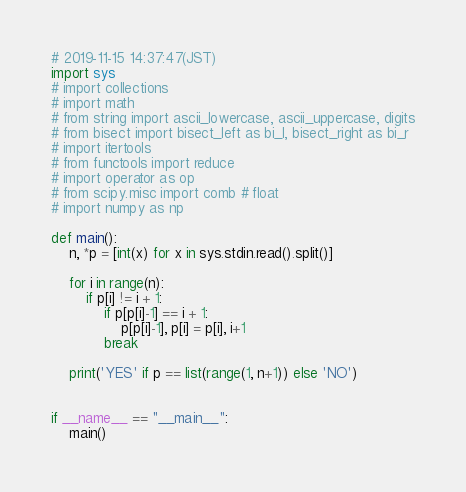<code> <loc_0><loc_0><loc_500><loc_500><_Python_># 2019-11-15 14:37:47(JST)
import sys
# import collections
# import math
# from string import ascii_lowercase, ascii_uppercase, digits
# from bisect import bisect_left as bi_l, bisect_right as bi_r
# import itertools
# from functools import reduce
# import operator as op
# from scipy.misc import comb # float
# import numpy as np 

def main():
    n, *p = [int(x) for x in sys.stdin.read().split()]

    for i in range(n):
        if p[i] != i + 1:
            if p[p[i]-1] == i + 1:
                p[p[i]-1], p[i] = p[i], i+1
            break

    print('YES' if p == list(range(1, n+1)) else 'NO')


if __name__ == "__main__":
    main()
</code> 